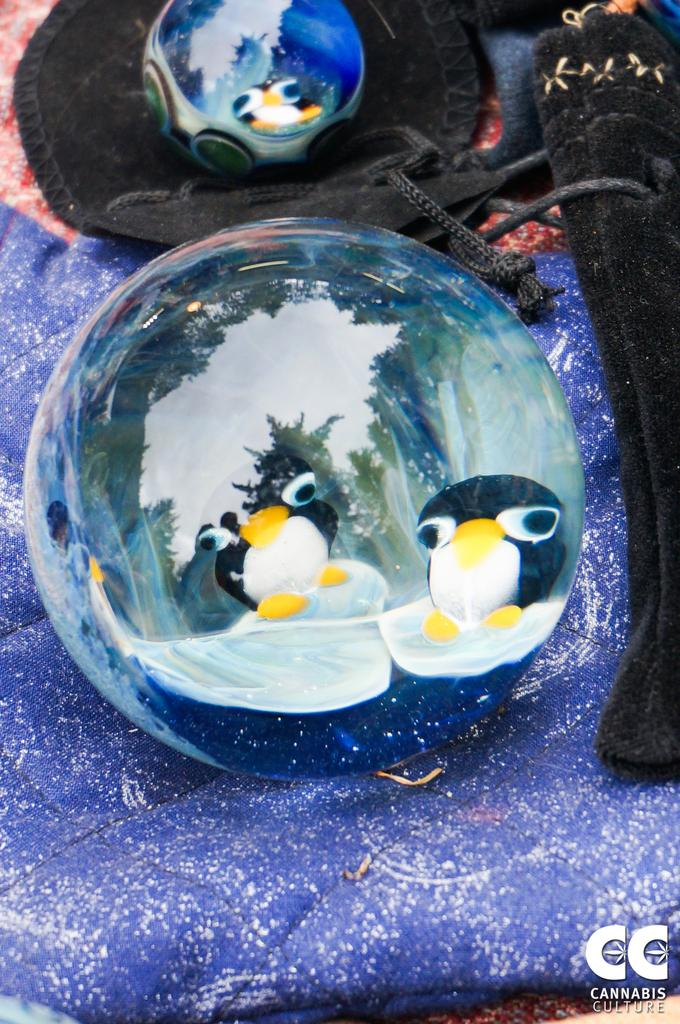How many balls are present in the image? There are two balls in the image. What is inside the balls? The balls contain toy penguins. Where are the balls located? The balls are on clothes. Is there any additional marking on the image? Yes, there is a watermark on the image. What type of wine is being served in the image? There is no wine present in the image; it features two balls containing toy penguins on clothes. How many geese are visible in the image? There are no geese present in the image. 